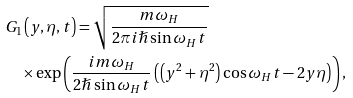<formula> <loc_0><loc_0><loc_500><loc_500>& G _ { 1 } \left ( y , \eta , t \right ) = \sqrt { \frac { m \omega _ { H } } { 2 \pi i \hslash \sin \omega _ { H } t } } \ \\ & \quad \times \exp \left ( \frac { i m \omega _ { H } } { 2 \hslash \sin \omega _ { H } t } \left ( \left ( y ^ { 2 } + \eta ^ { 2 } \right ) \cos \omega _ { H } t - 2 y \eta \right ) \right ) ,</formula> 